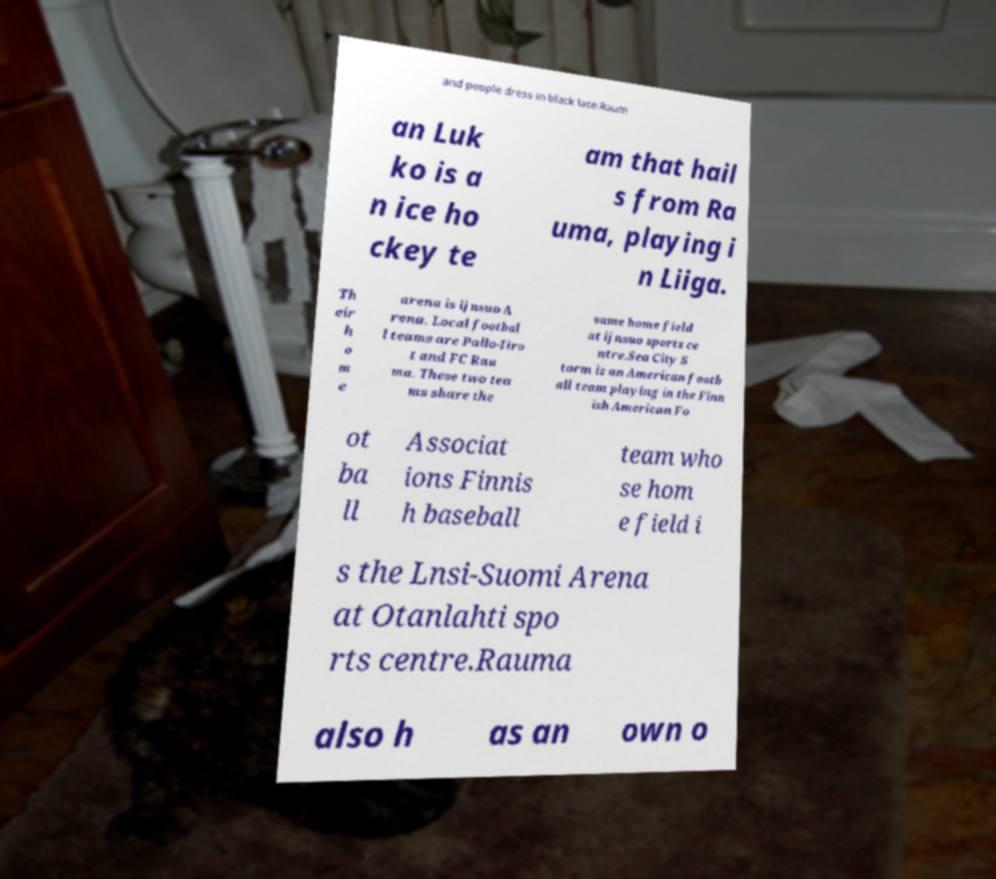I need the written content from this picture converted into text. Can you do that? and people dress in black lace.Raum an Luk ko is a n ice ho ckey te am that hail s from Ra uma, playing i n Liiga. Th eir h o m e arena is ijnsuo A rena. Local footbal l teams are Pallo-Iiro t and FC Rau ma. These two tea ms share the same home field at ijnsuo sports ce ntre.Sea City S torm is an American footb all team playing in the Finn ish American Fo ot ba ll Associat ions Finnis h baseball team who se hom e field i s the Lnsi-Suomi Arena at Otanlahti spo rts centre.Rauma also h as an own o 